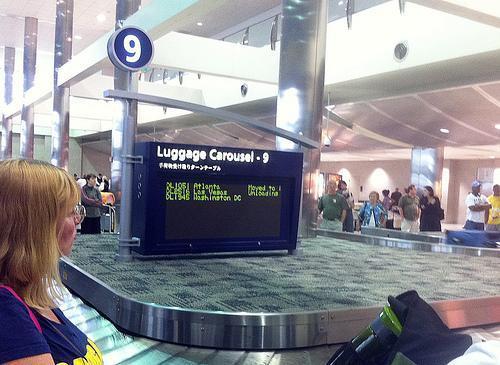How many pieces of luggage can be seen?
Give a very brief answer. 1. 